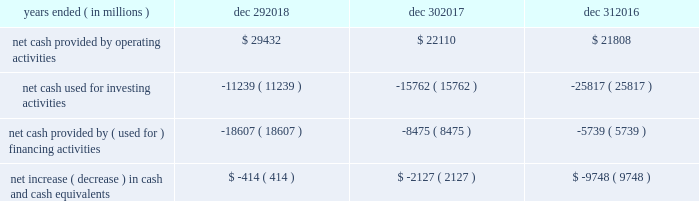Sources and uses of cash ( in millions ) in summary , our cash flows for each period were as follows : years ended ( in millions ) dec 29 , dec 30 , dec 31 .
Md&a consolidated results and analysis 40 .
As of december 292017 what was the percent of the net cash used for investing activities to the net cash provided by operating activities? 
Rationale: as of december 292018 38.2% of net cash provided by operating activities was used for the used for investing activities
Computations: (11239 / 29432)
Answer: 0.38186. 